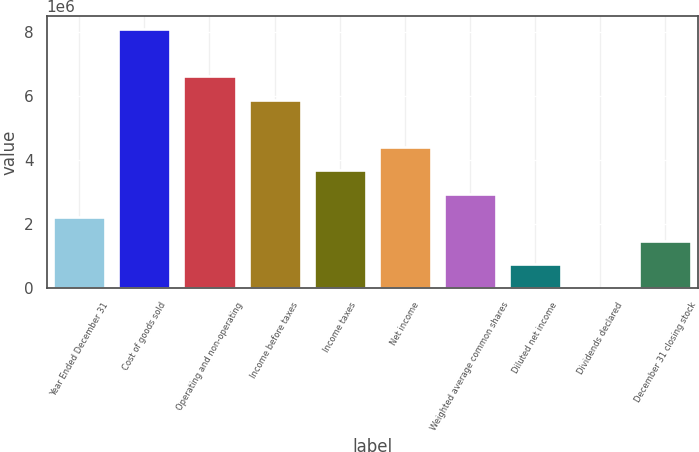<chart> <loc_0><loc_0><loc_500><loc_500><bar_chart><fcel>Year Ended December 31<fcel>Cost of goods sold<fcel>Operating and non-operating<fcel>Income before taxes<fcel>Income taxes<fcel>Net income<fcel>Weighted average common shares<fcel>Diluted net income<fcel>Dividends declared<fcel>December 31 closing stock<nl><fcel>2.20604e+06<fcel>8.08879e+06<fcel>6.6181e+06<fcel>5.88276e+06<fcel>3.67672e+06<fcel>4.41207e+06<fcel>2.94138e+06<fcel>735346<fcel>1.35<fcel>1.47069e+06<nl></chart> 